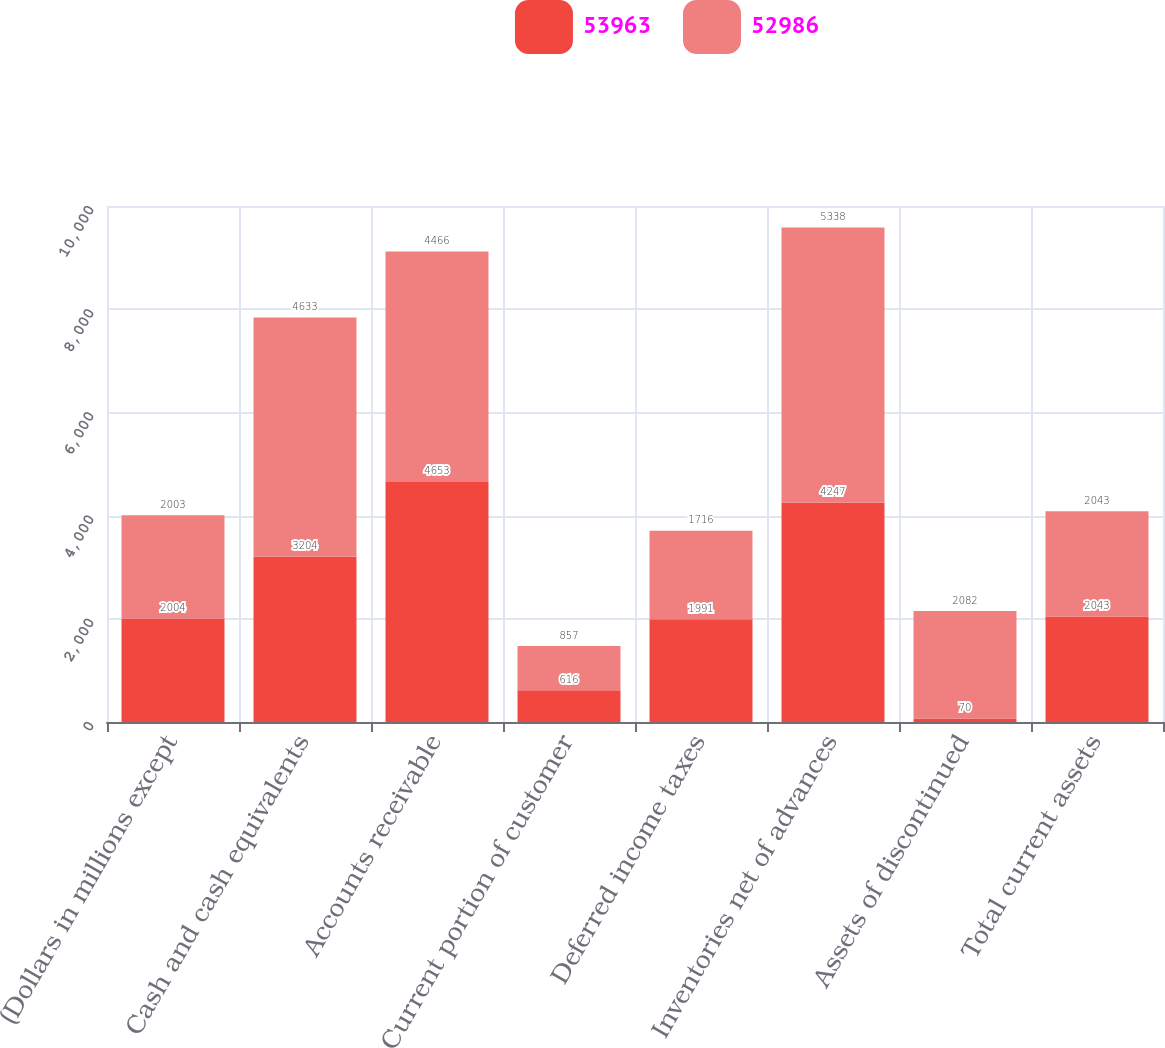Convert chart to OTSL. <chart><loc_0><loc_0><loc_500><loc_500><stacked_bar_chart><ecel><fcel>(Dollars in millions except<fcel>Cash and cash equivalents<fcel>Accounts receivable<fcel>Current portion of customer<fcel>Deferred income taxes<fcel>Inventories net of advances<fcel>Assets of discontinued<fcel>Total current assets<nl><fcel>53963<fcel>2004<fcel>3204<fcel>4653<fcel>616<fcel>1991<fcel>4247<fcel>70<fcel>2043<nl><fcel>52986<fcel>2003<fcel>4633<fcel>4466<fcel>857<fcel>1716<fcel>5338<fcel>2082<fcel>2043<nl></chart> 